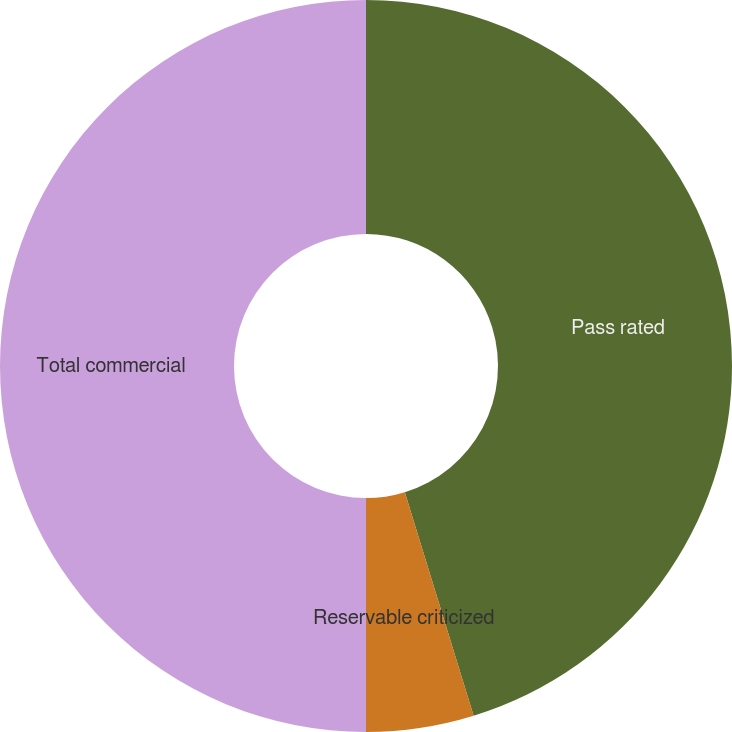<chart> <loc_0><loc_0><loc_500><loc_500><pie_chart><fcel>Pass rated<fcel>Reservable criticized<fcel>Total commercial<nl><fcel>45.25%<fcel>4.75%<fcel>50.0%<nl></chart> 